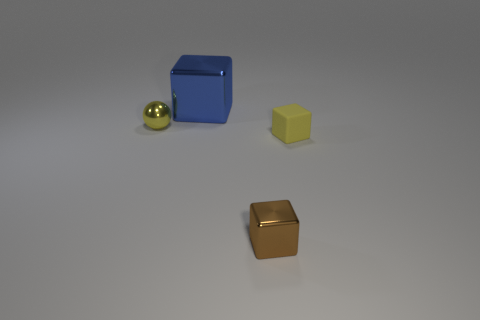Subtract all blue cubes. How many cubes are left? 2 Subtract all yellow cubes. How many cubes are left? 2 Subtract all blue spheres. How many blue cubes are left? 1 Subtract 1 brown cubes. How many objects are left? 3 Subtract all cubes. How many objects are left? 1 Subtract all gray blocks. Subtract all cyan cylinders. How many blocks are left? 3 Subtract all large cyan matte cylinders. Subtract all rubber blocks. How many objects are left? 3 Add 4 tiny brown blocks. How many tiny brown blocks are left? 5 Add 4 blue objects. How many blue objects exist? 5 Add 2 metallic cubes. How many objects exist? 6 